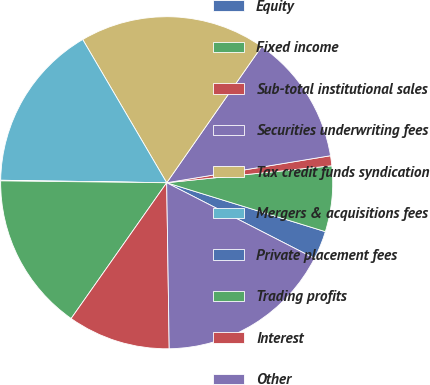<chart> <loc_0><loc_0><loc_500><loc_500><pie_chart><fcel>Equity<fcel>Fixed income<fcel>Sub-total institutional sales<fcel>Securities underwriting fees<fcel>Tax credit funds syndication<fcel>Mergers & acquisitions fees<fcel>Private placement fees<fcel>Trading profits<fcel>Interest<fcel>Other<nl><fcel>2.77%<fcel>6.39%<fcel>0.97%<fcel>12.71%<fcel>18.13%<fcel>16.32%<fcel>0.06%<fcel>15.42%<fcel>10.0%<fcel>17.23%<nl></chart> 